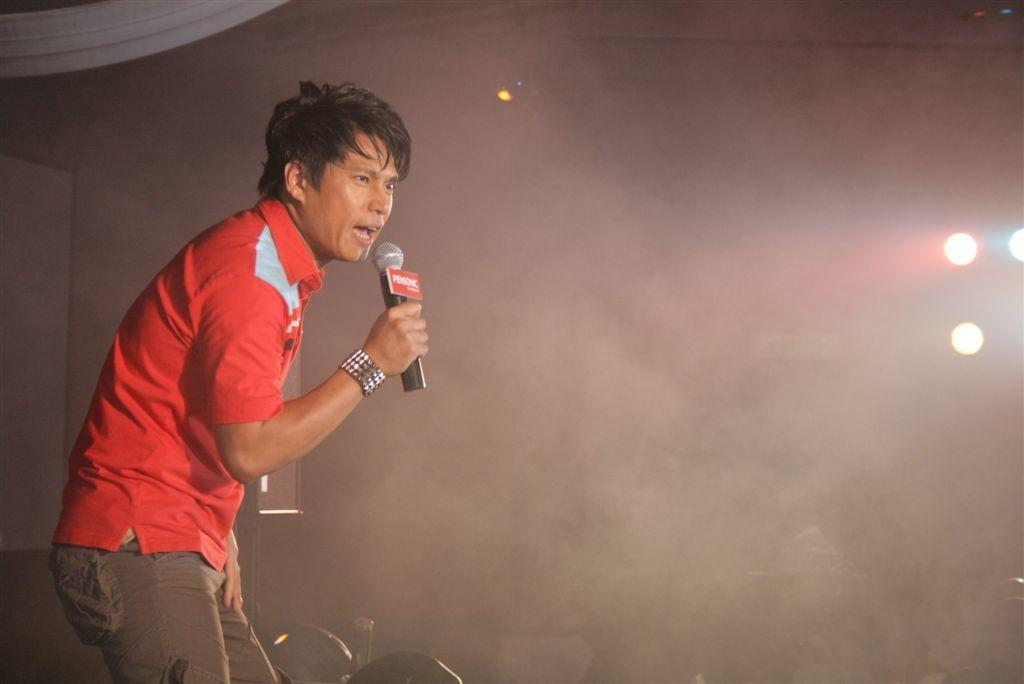Who is the main subject in the image? There is a man in the image. What is the man holding in his hand? The man is holding a microphone in his hand. What might the man be doing with the microphone? The man appears to be singing, as he is holding a microphone. What type of territory is the man trying to claim in the image? There is no indication of territory or any claim in the image; it simply shows a man holding a microphone. 